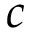Convert formula to latex. <formula><loc_0><loc_0><loc_500><loc_500>c</formula> 